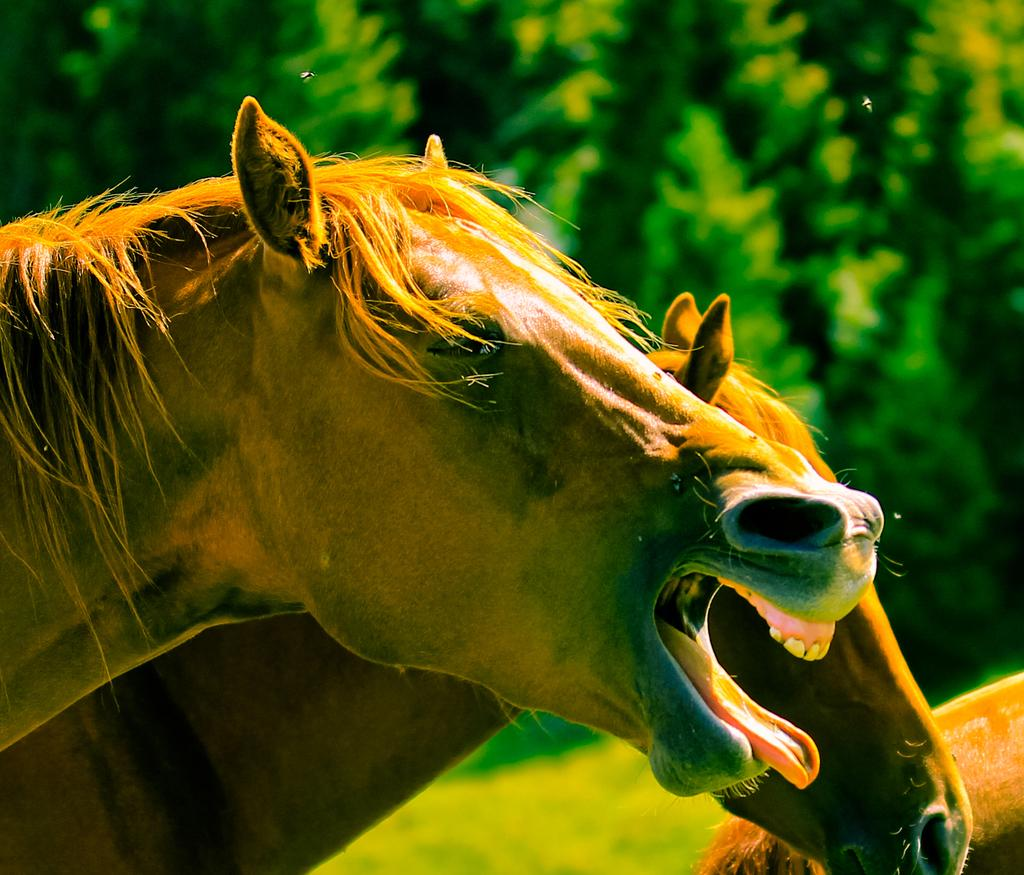What animals can be seen in the image? There are horses in the image. What type of vegetation is present in the image? There is grass in the image. What other natural elements can be seen in the image? There are trees in the image. What type of drain is visible in the image? There is no drain present in the image. 